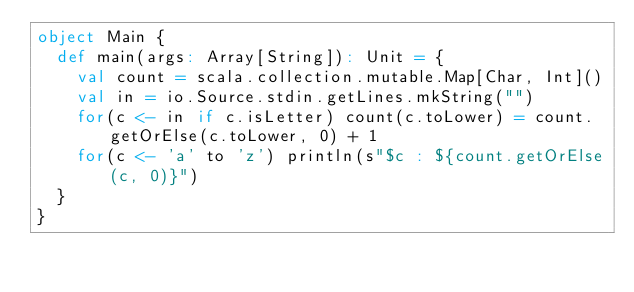<code> <loc_0><loc_0><loc_500><loc_500><_Scala_>object Main {
  def main(args: Array[String]): Unit = {
    val count = scala.collection.mutable.Map[Char, Int]()
    val in = io.Source.stdin.getLines.mkString("")
    for(c <- in if c.isLetter) count(c.toLower) = count.getOrElse(c.toLower, 0) + 1
    for(c <- 'a' to 'z') println(s"$c : ${count.getOrElse(c, 0)}")
  }
}

</code> 